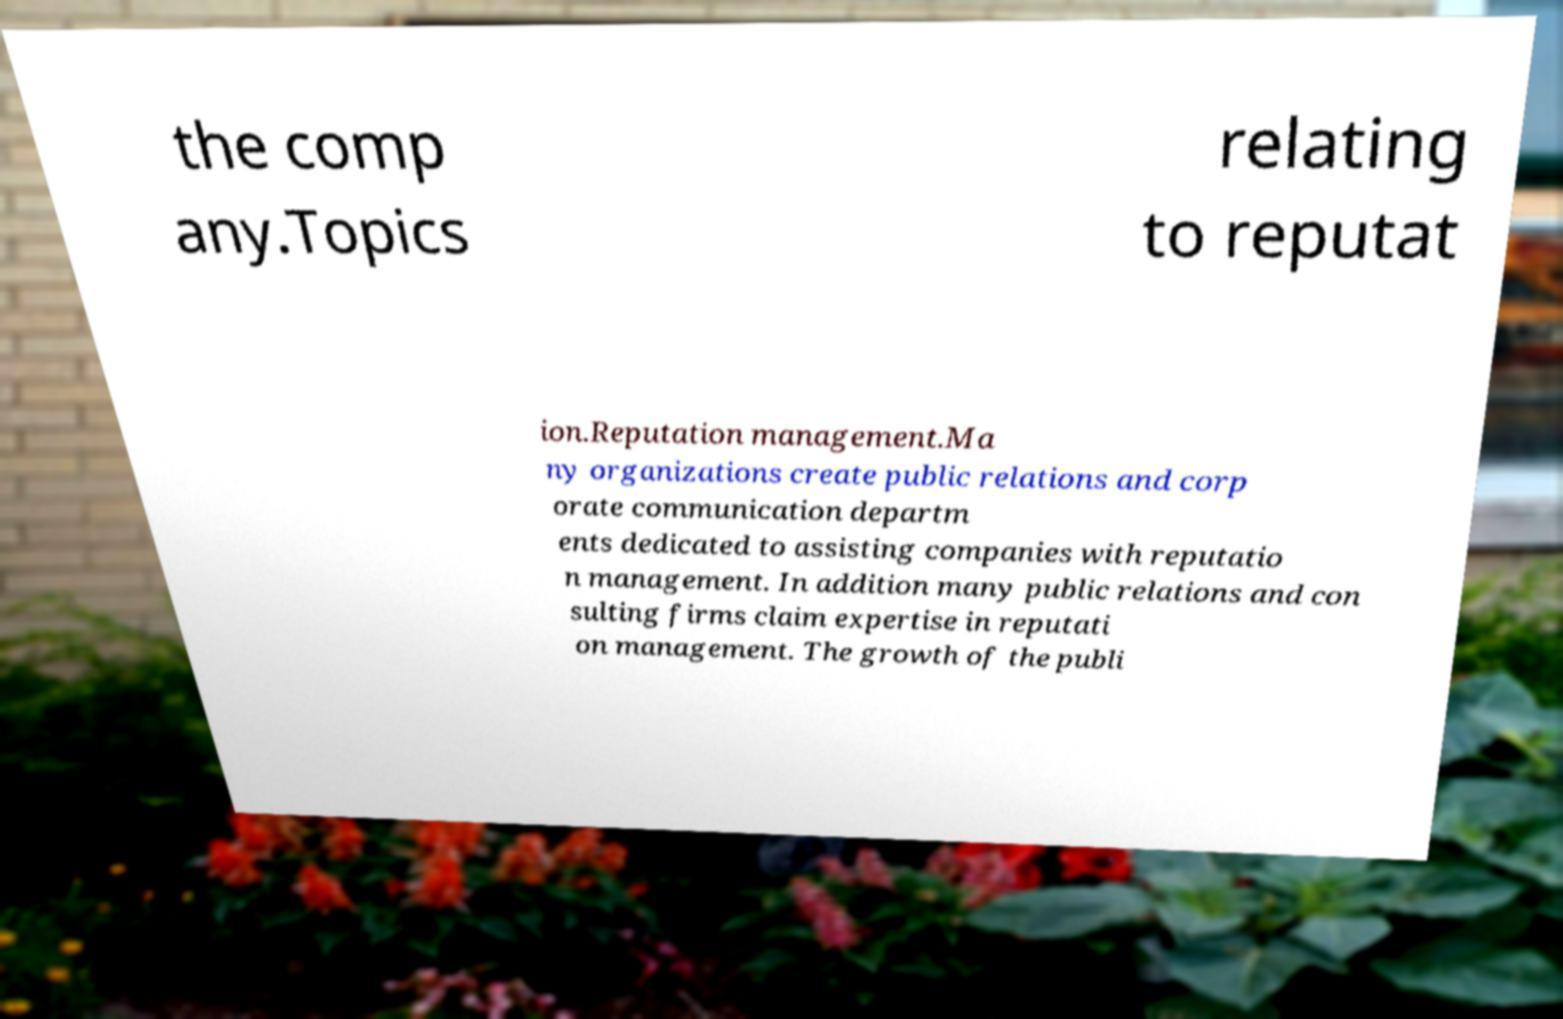Can you accurately transcribe the text from the provided image for me? the comp any.Topics relating to reputat ion.Reputation management.Ma ny organizations create public relations and corp orate communication departm ents dedicated to assisting companies with reputatio n management. In addition many public relations and con sulting firms claim expertise in reputati on management. The growth of the publi 